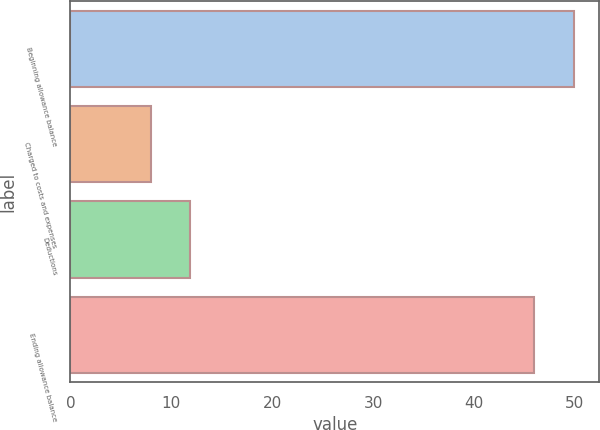Convert chart to OTSL. <chart><loc_0><loc_0><loc_500><loc_500><bar_chart><fcel>Beginning allowance balance<fcel>Charged to costs and expenses<fcel>Deductions<fcel>Ending allowance balance<nl><fcel>49.9<fcel>8<fcel>11.9<fcel>46<nl></chart> 